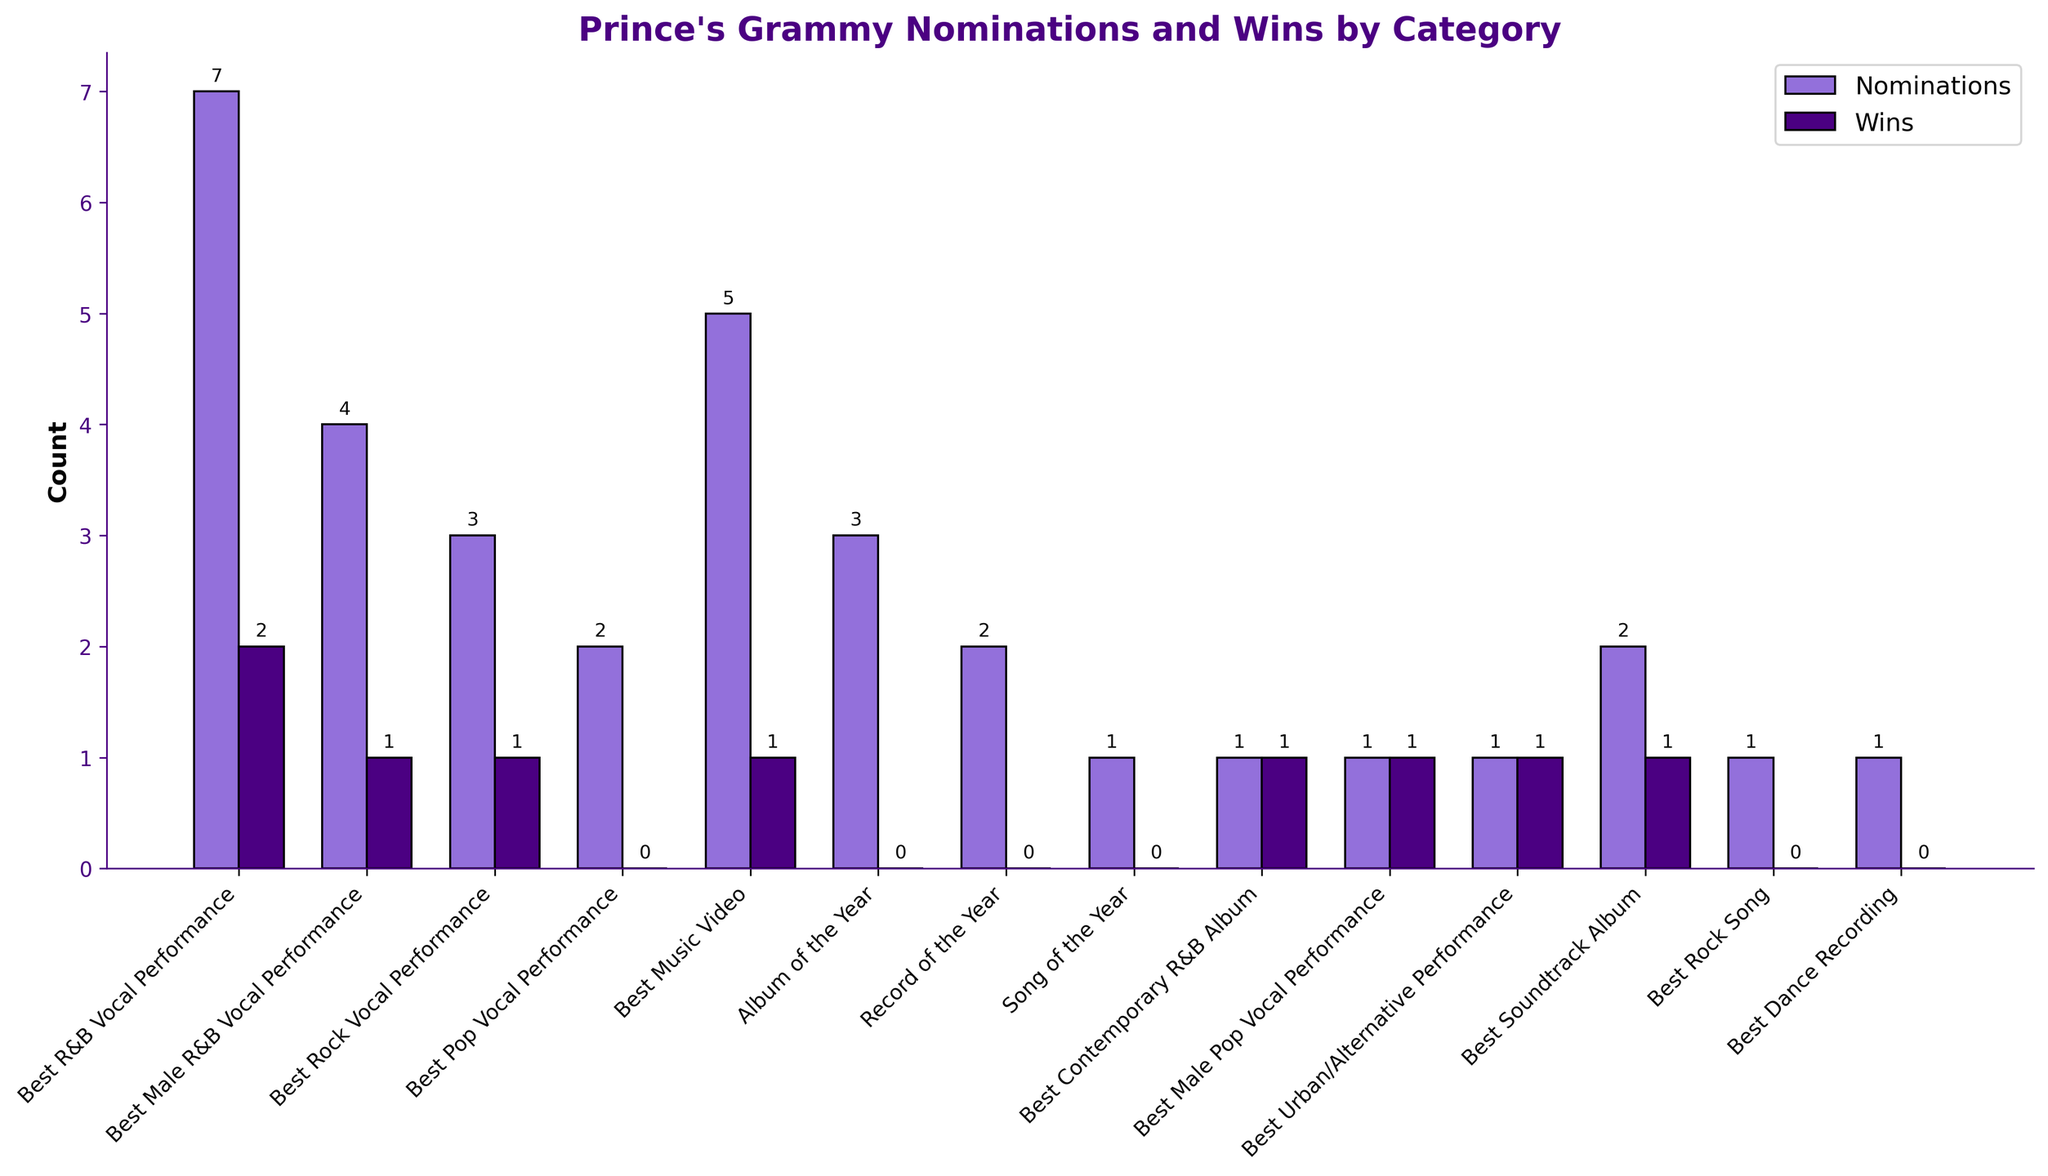Which category received the most nominations for Prince? The tallest bar in the 'Nominations' group indicates the category with the most nominations. Comparing the heights, 'Best R&B Vocal Performance' has the highest bar with 7 nominations.
Answer: Best R&B Vocal Performance How many total wins did Prince have across all categories? Sum the heights of all 'Wins' bars. The total wins are 9 (2+1+1+1+1+1+1+1).
Answer: 9 Which category did Prince win at least 1 Grammy but had fewer than 3 nominations? Look for categories where the 'Wins' bar is non-zero and the 'Nominations' bar is less than 3. 'Best Contemporary R&B Album', 'Best Male Pop Vocal Performance', 'Best Urban/Alternative Performance', and 'Best Rock Song' fit this criterion.
Answer: Best Contemporary R&B Album, Best Male Pop Vocal Performance, Best Urban/Alternative Performance How many categories did Prince receive nominations but did not win any Grammy? Count the categories where the 'Wins' bar is zero. There are five such categories: 'Best Pop Vocal Performance', 'Album of the Year', 'Record of the Year', 'Song of the Year', and 'Best Rock Song'.
Answer: 5 What is the ratio of nominations to wins for 'Best Music Video'? The nominations are 5, and wins are 1. The ratio is calculated as 5/1.
Answer: 5:1 Which categories did Prince perform best in, based on nominations-to-wins ratio? Calculate the ratio of nominations to wins for each category. Categories with a ratio of 1 (or close to it) are 'Best Male R&B Vocal Performance', 'Best Rock Vocal Performance', 'Best Contemporary R&B Album', 'Best Male Pop Vocal Performance', 'Best Urban/Alternative Performance', and 'Best Soundtrack Album'.
Answer: Best Contemporary R&B Album, Best Male Pop Vocal Performance, Best Urban/Alternative Performance, Best Soundtrack Album What is the difference in the height of the bars for nominations and wins in 'Best R&B Vocal Performance'? The height difference between nominations (7) and wins (2) is calculated as 7 - 2.
Answer: 5 How many Grammy categories did Prince receive a nomination in? Count the total number of distinct categories shown on the x-axis. There are 14 categories.
Answer: 14 For which category is the discrepancy between nominations and wins the greatest? Calculate the difference between nominations and wins for each category. The largest difference is found in 'Best R&B Vocal Performance' (7 - 2 = 5).
Answer: Best R&B Vocal Performance 